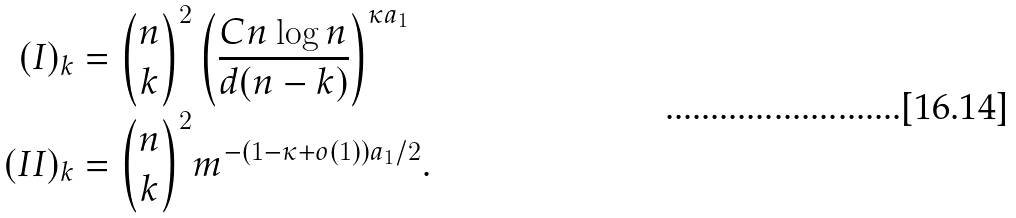<formula> <loc_0><loc_0><loc_500><loc_500>( I ) _ { k } & = { n \choose k } ^ { 2 } \left ( \frac { C n \log n } { d ( n - k ) } \right ) ^ { \kappa a _ { 1 } } \\ ( I I ) _ { k } & = { n \choose k } ^ { 2 } m ^ { - ( 1 - \kappa + o ( 1 ) ) a _ { 1 } / 2 } .</formula> 